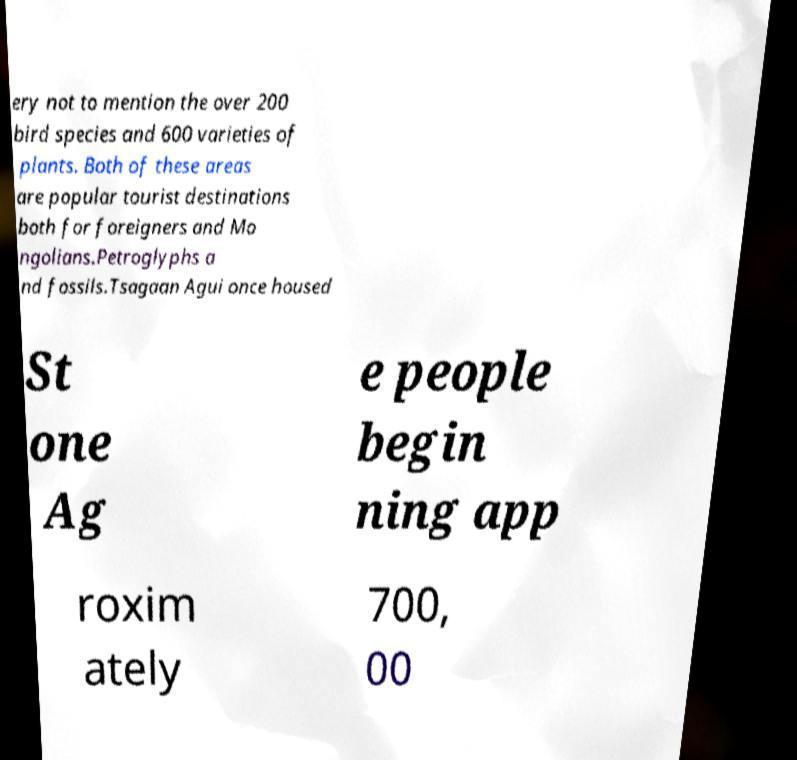Can you accurately transcribe the text from the provided image for me? ery not to mention the over 200 bird species and 600 varieties of plants. Both of these areas are popular tourist destinations both for foreigners and Mo ngolians.Petroglyphs a nd fossils.Tsagaan Agui once housed St one Ag e people begin ning app roxim ately 700, 00 